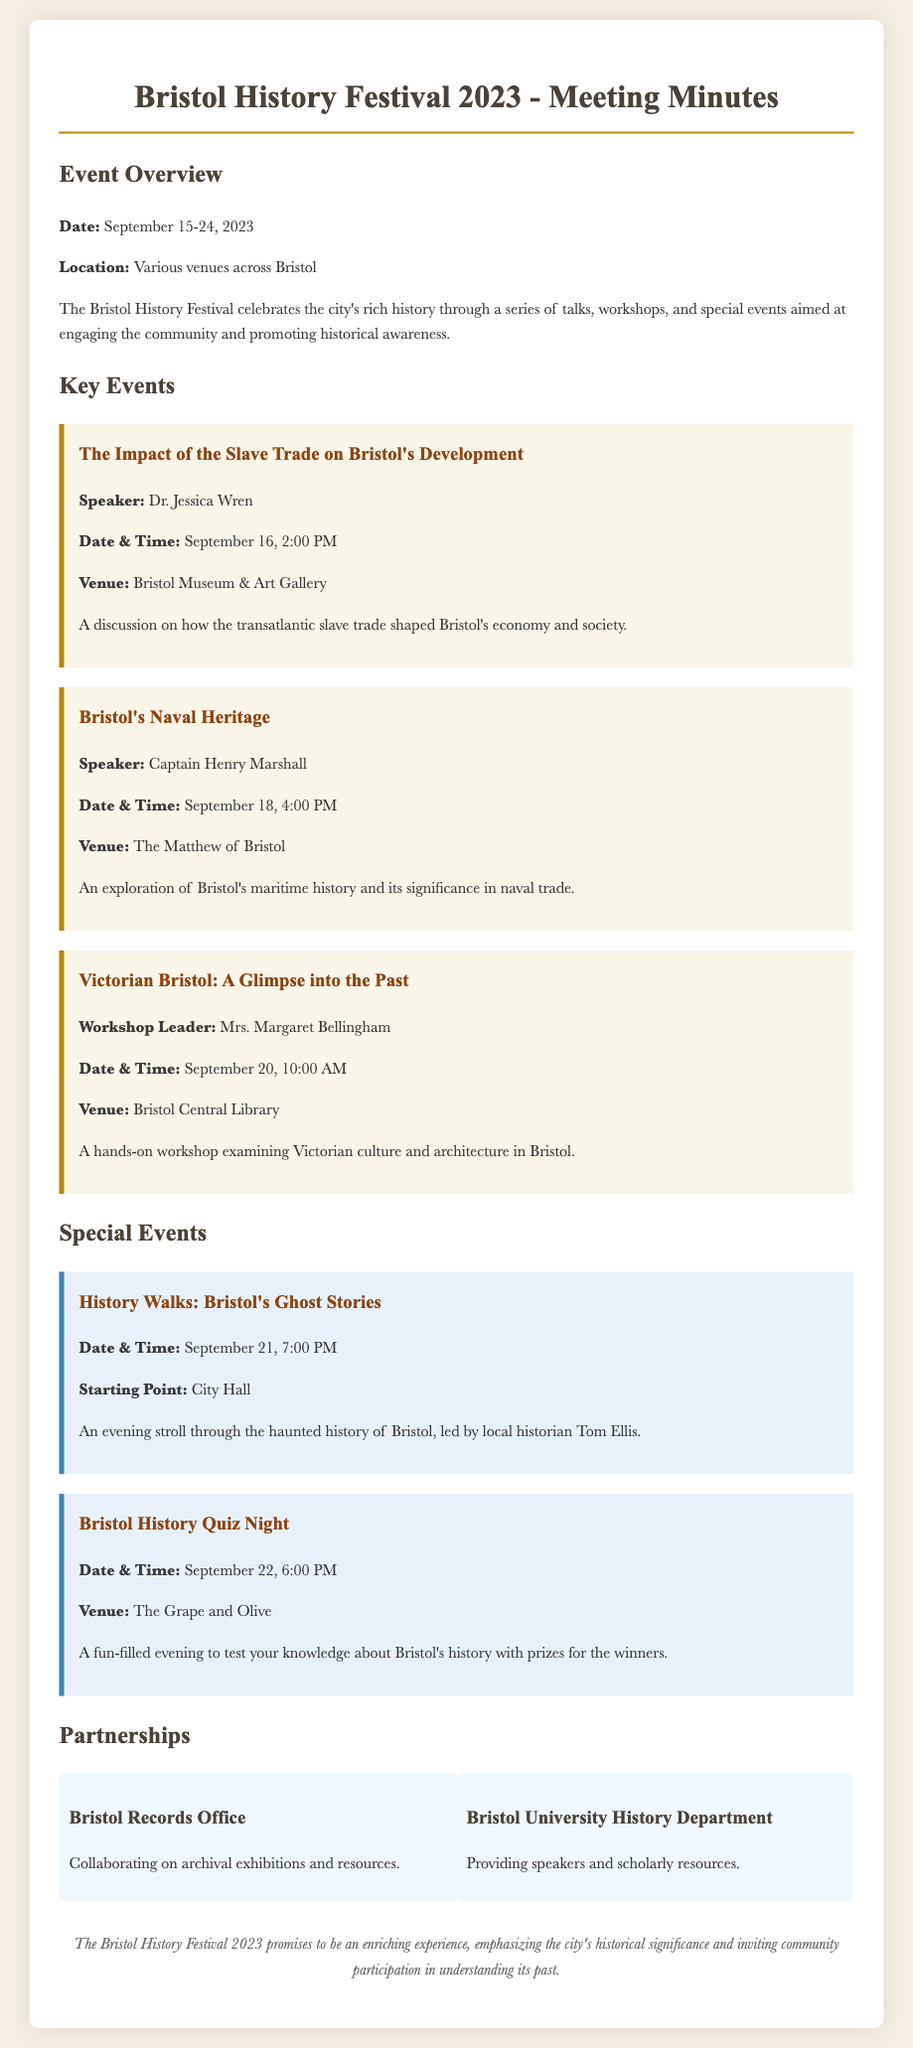what is the date of the Bristol History Festival? The date of the festival is provided in the event overview section and is September 15-24, 2023.
Answer: September 15-24, 2023 who is the speaker for the event on the slave trade? The name of the speaker for the event discussing the slave trade is mentioned in the key events section.
Answer: Dr. Jessica Wren what is the venue for the workshop on Victorian culture? The venue for the specific workshop mentioned is included in the event details under key events.
Answer: Bristol Central Library when does the Bristol History Quiz Night take place? The date and time for the quiz night are provided in the special events section of the document.
Answer: September 22, 6:00 PM which department is providing speakers for the festival? The department's contribution is mentioned in the partnerships section of the meeting minutes.
Answer: Bristol University History Department what is the starting point for the Bristol's Ghost Stories walk? The starting point for the ghost stories event is specified in the description of that event.
Answer: City Hall how many special events are listed in the document? The document lists the special events separately, allowing for a count of them.
Answer: 2 who leads the workshop on Victorian Bristol? The workshop leader's name is stated in the description of the Victorian Bristol workshop in the key events section.
Answer: Mrs. Margaret Bellingham 